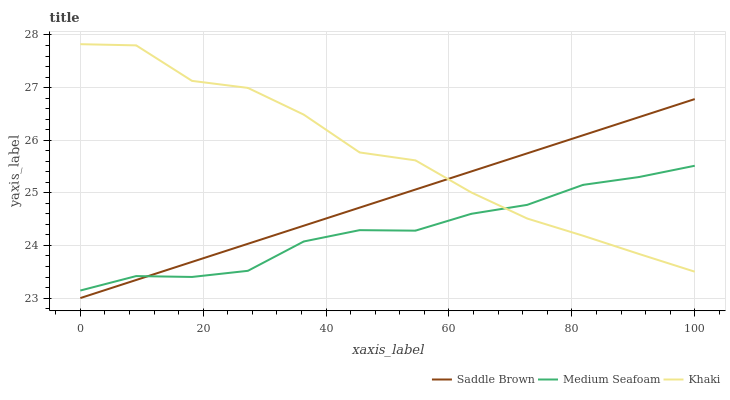Does Medium Seafoam have the minimum area under the curve?
Answer yes or no. Yes. Does Khaki have the maximum area under the curve?
Answer yes or no. Yes. Does Saddle Brown have the minimum area under the curve?
Answer yes or no. No. Does Saddle Brown have the maximum area under the curve?
Answer yes or no. No. Is Saddle Brown the smoothest?
Answer yes or no. Yes. Is Khaki the roughest?
Answer yes or no. Yes. Is Medium Seafoam the smoothest?
Answer yes or no. No. Is Medium Seafoam the roughest?
Answer yes or no. No. Does Saddle Brown have the lowest value?
Answer yes or no. Yes. Does Medium Seafoam have the lowest value?
Answer yes or no. No. Does Khaki have the highest value?
Answer yes or no. Yes. Does Saddle Brown have the highest value?
Answer yes or no. No. Does Khaki intersect Medium Seafoam?
Answer yes or no. Yes. Is Khaki less than Medium Seafoam?
Answer yes or no. No. Is Khaki greater than Medium Seafoam?
Answer yes or no. No. 